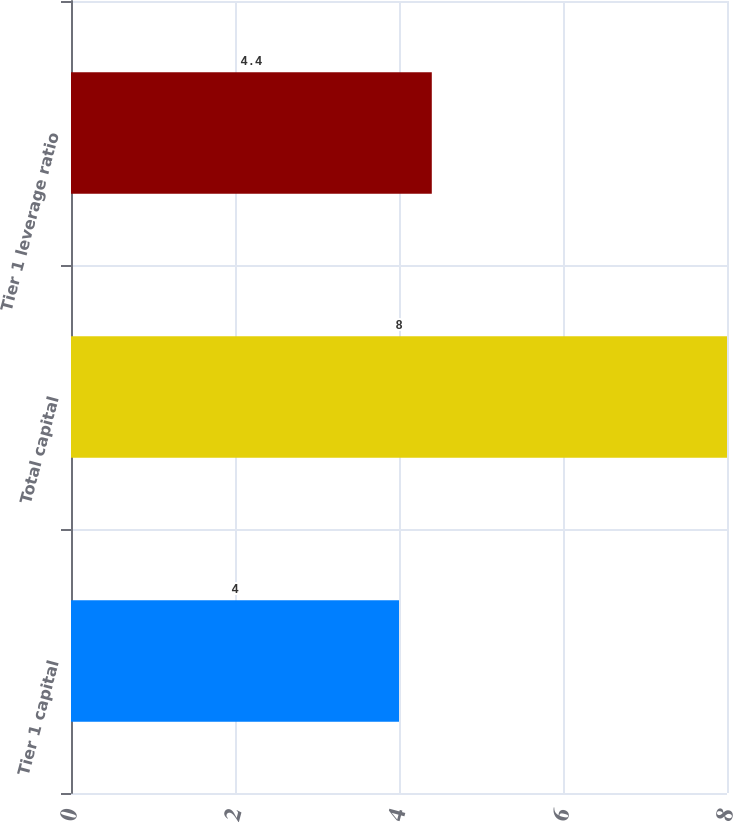<chart> <loc_0><loc_0><loc_500><loc_500><bar_chart><fcel>Tier 1 capital<fcel>Total capital<fcel>Tier 1 leverage ratio<nl><fcel>4<fcel>8<fcel>4.4<nl></chart> 